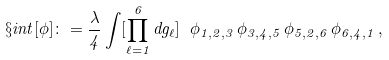<formula> <loc_0><loc_0><loc_500><loc_500>\S i n t [ \phi ] \colon = \frac { \lambda } { 4 } \int [ \prod _ { \ell = 1 } ^ { 6 } d g _ { \ell } ] \ \phi _ { 1 , 2 , 3 } \, \phi _ { 3 , 4 , 5 } \, \phi _ { 5 , 2 , 6 } \, \phi _ { 6 , 4 , 1 } \, ,</formula> 